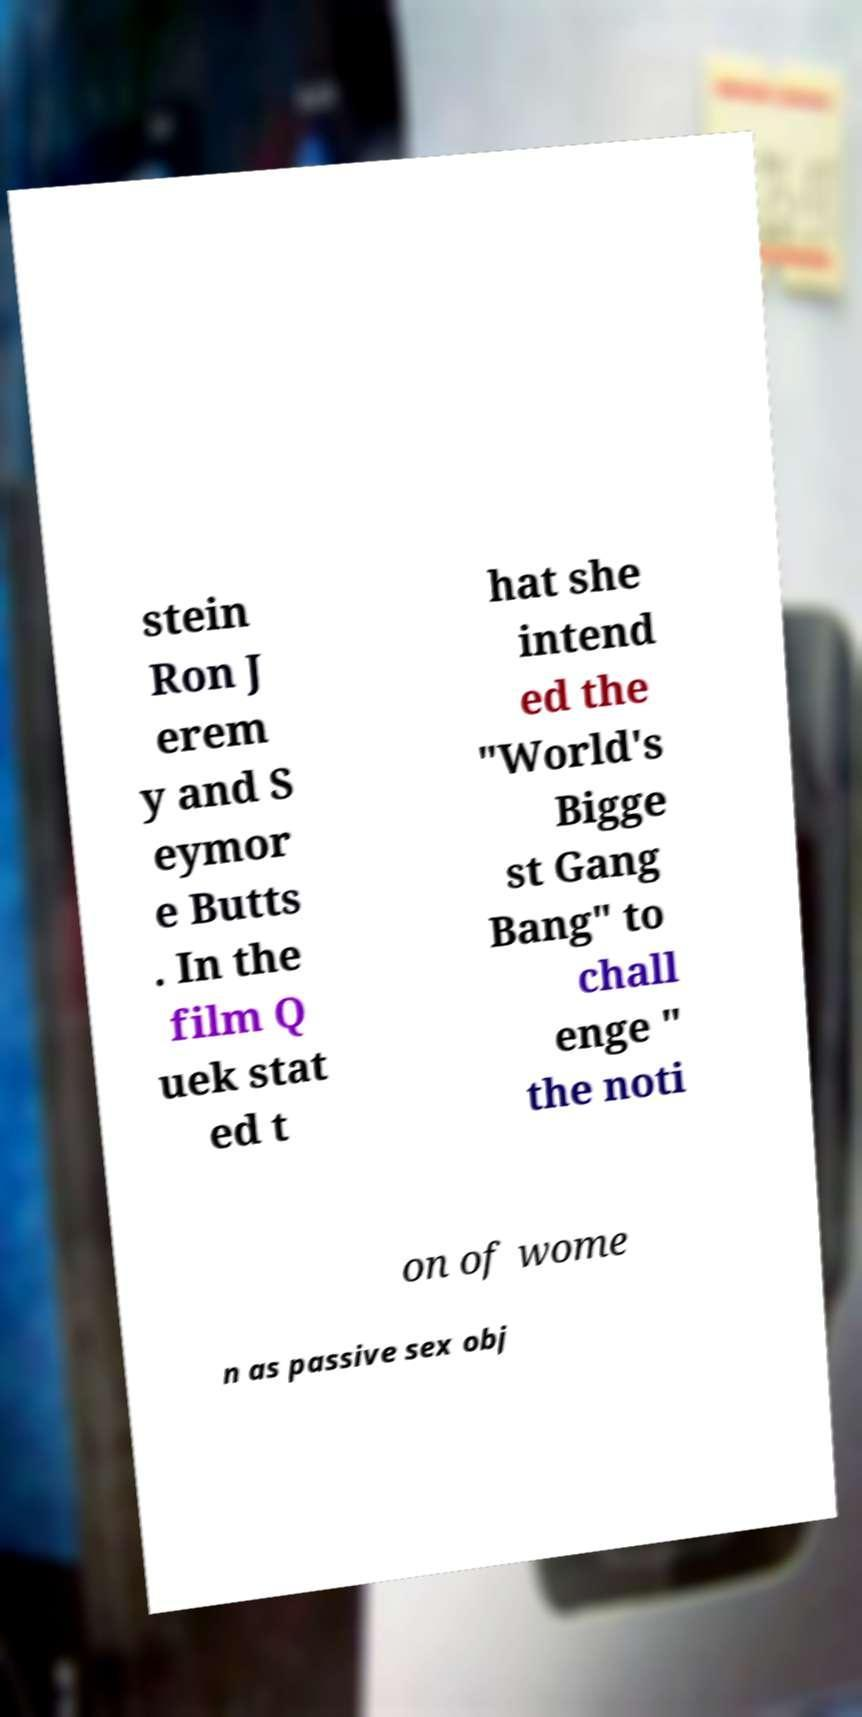Please read and relay the text visible in this image. What does it say? stein Ron J erem y and S eymor e Butts . In the film Q uek stat ed t hat she intend ed the "World's Bigge st Gang Bang" to chall enge " the noti on of wome n as passive sex obj 